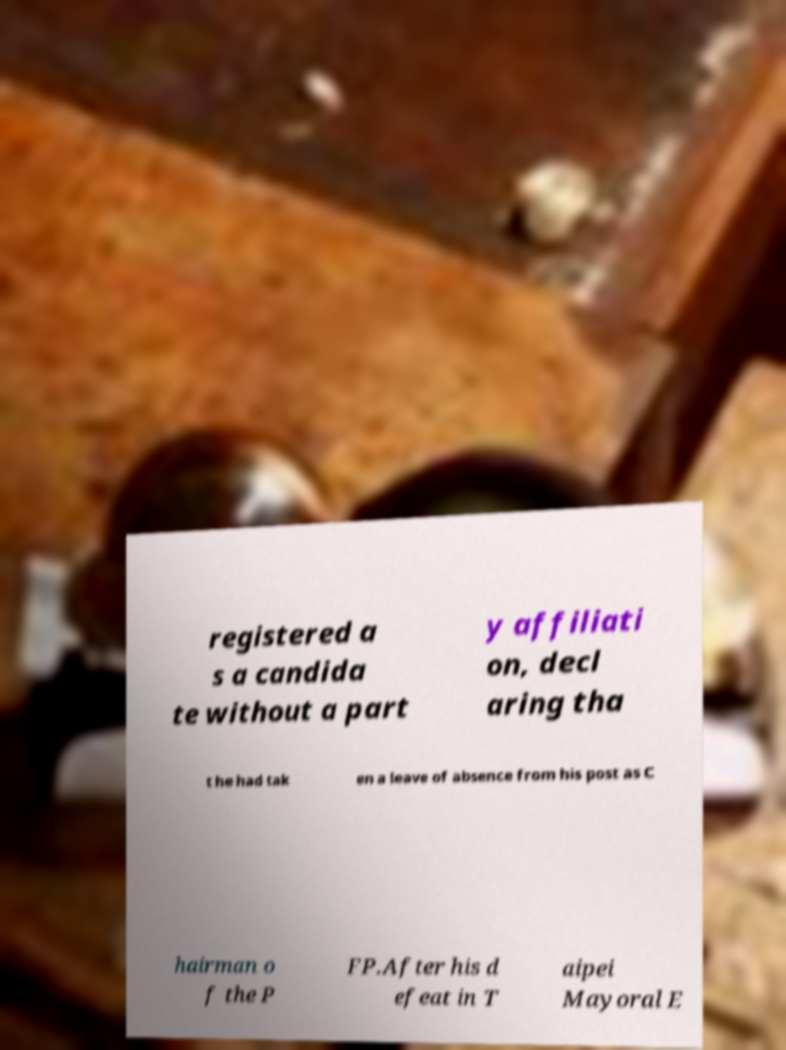For documentation purposes, I need the text within this image transcribed. Could you provide that? registered a s a candida te without a part y affiliati on, decl aring tha t he had tak en a leave of absence from his post as C hairman o f the P FP.After his d efeat in T aipei Mayoral E 